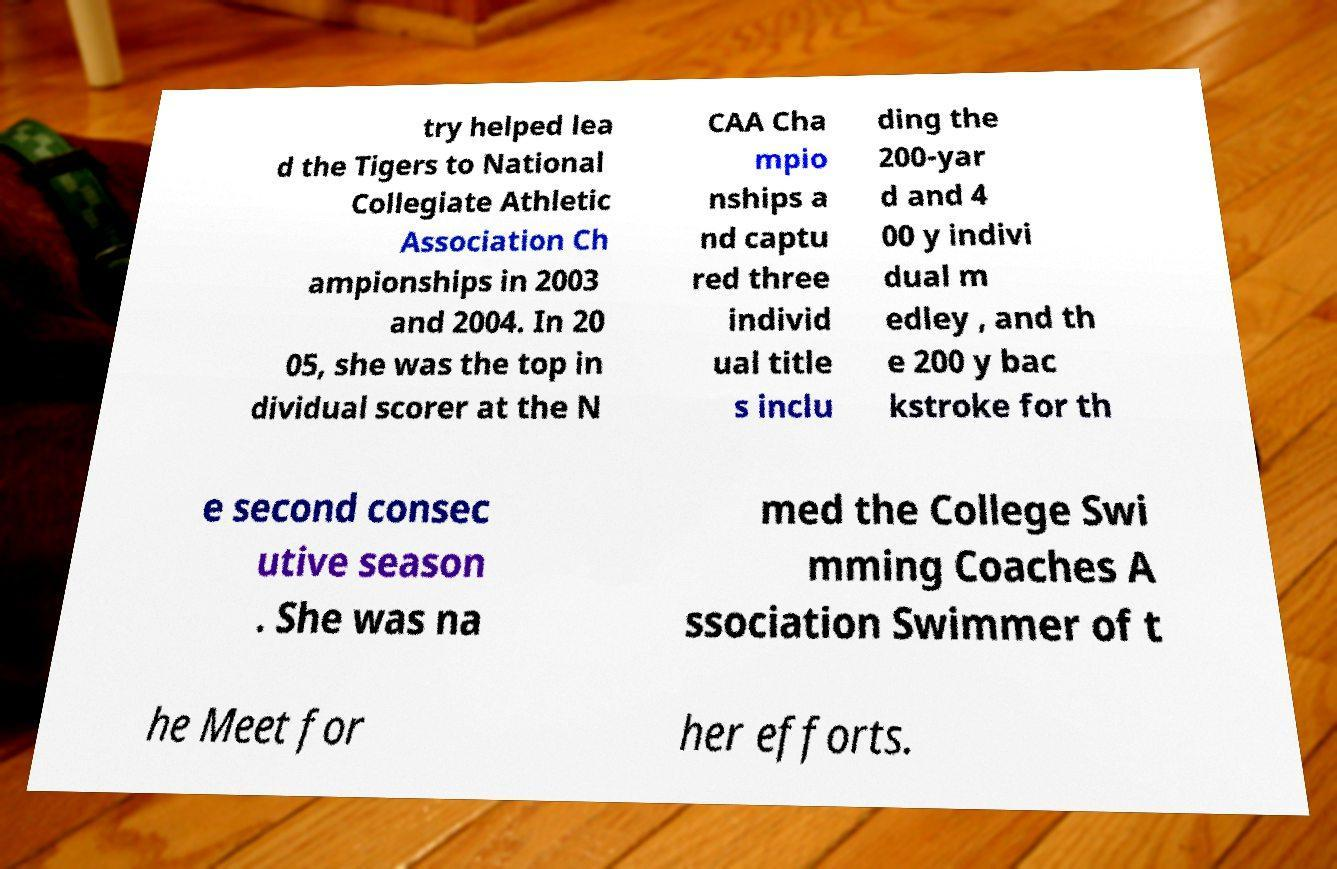Could you assist in decoding the text presented in this image and type it out clearly? try helped lea d the Tigers to National Collegiate Athletic Association Ch ampionships in 2003 and 2004. In 20 05, she was the top in dividual scorer at the N CAA Cha mpio nships a nd captu red three individ ual title s inclu ding the 200-yar d and 4 00 y indivi dual m edley , and th e 200 y bac kstroke for th e second consec utive season . She was na med the College Swi mming Coaches A ssociation Swimmer of t he Meet for her efforts. 